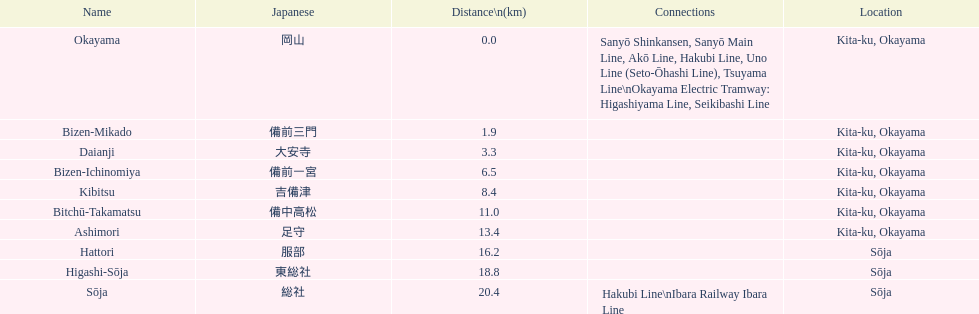How many stations have a distance under 15km? 7. 